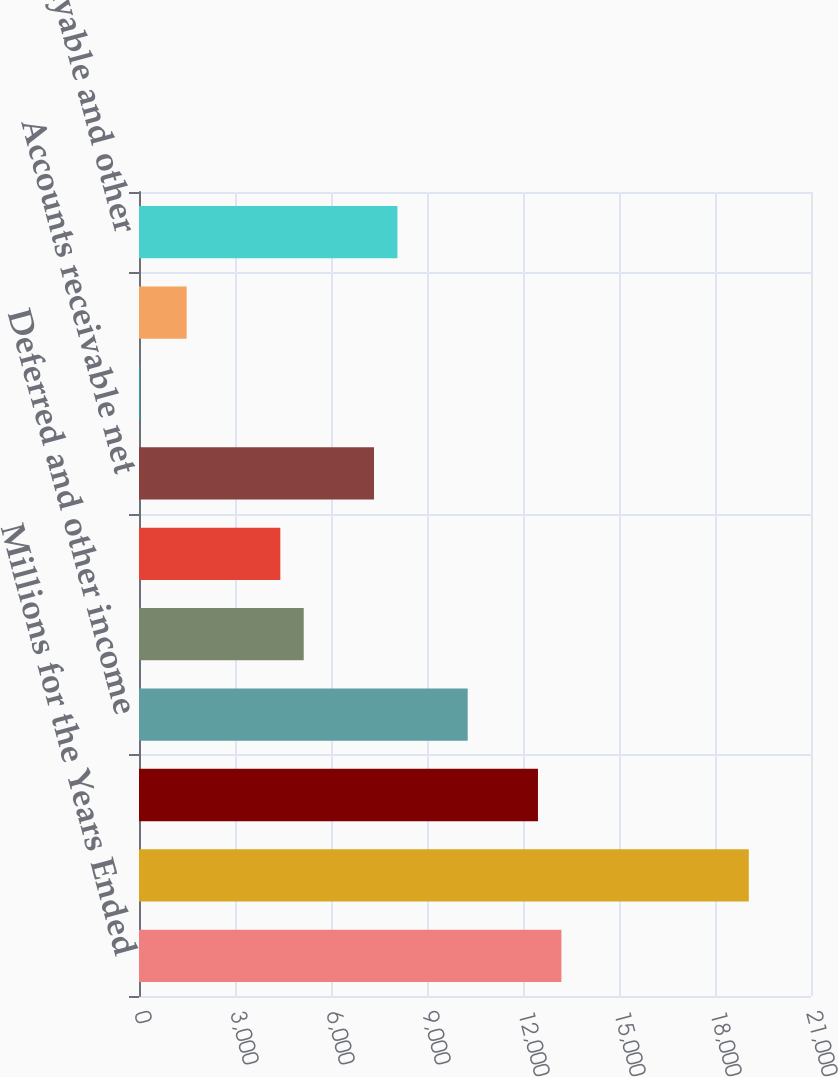Convert chart. <chart><loc_0><loc_0><loc_500><loc_500><bar_chart><fcel>Millions for the Years Ended<fcel>Net income<fcel>Depreciation<fcel>Deferred and other income<fcel>Net gain on non-operating<fcel>Other operating activities net<fcel>Accounts receivable net<fcel>Materials and supplies<fcel>Other current assets<fcel>Accounts payable and other<nl><fcel>13200<fcel>19056<fcel>12468<fcel>10272<fcel>5148<fcel>4416<fcel>7344<fcel>24<fcel>1488<fcel>8076<nl></chart> 